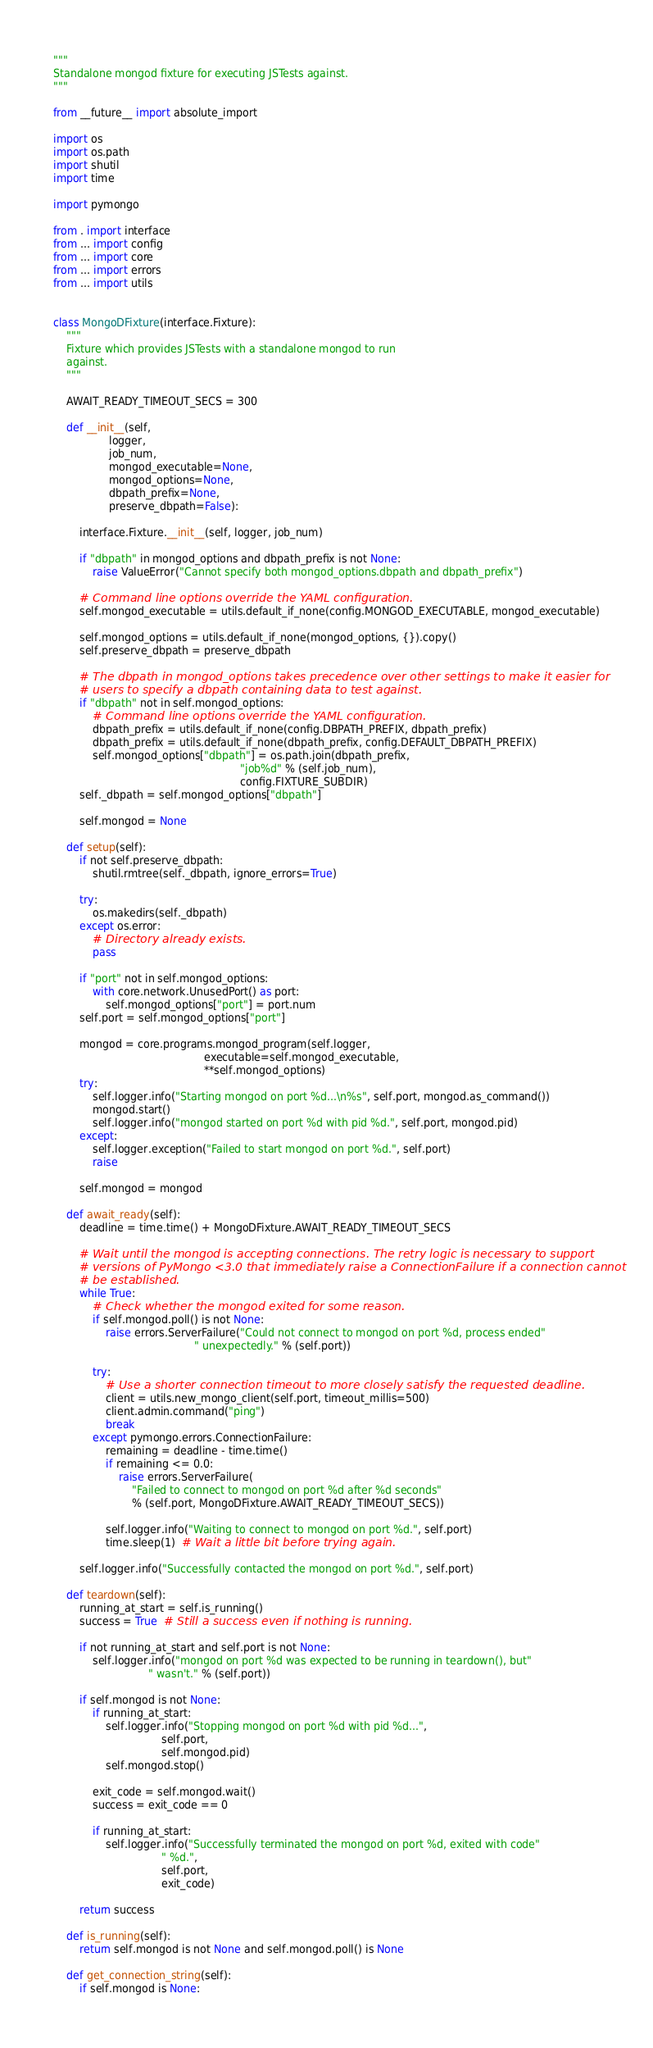<code> <loc_0><loc_0><loc_500><loc_500><_Python_>"""
Standalone mongod fixture for executing JSTests against.
"""

from __future__ import absolute_import

import os
import os.path
import shutil
import time

import pymongo

from . import interface
from ... import config
from ... import core
from ... import errors
from ... import utils


class MongoDFixture(interface.Fixture):
    """
    Fixture which provides JSTests with a standalone mongod to run
    against.
    """

    AWAIT_READY_TIMEOUT_SECS = 300

    def __init__(self,
                 logger,
                 job_num,
                 mongod_executable=None,
                 mongod_options=None,
                 dbpath_prefix=None,
                 preserve_dbpath=False):

        interface.Fixture.__init__(self, logger, job_num)

        if "dbpath" in mongod_options and dbpath_prefix is not None:
            raise ValueError("Cannot specify both mongod_options.dbpath and dbpath_prefix")

        # Command line options override the YAML configuration.
        self.mongod_executable = utils.default_if_none(config.MONGOD_EXECUTABLE, mongod_executable)

        self.mongod_options = utils.default_if_none(mongod_options, {}).copy()
        self.preserve_dbpath = preserve_dbpath

        # The dbpath in mongod_options takes precedence over other settings to make it easier for
        # users to specify a dbpath containing data to test against.
        if "dbpath" not in self.mongod_options:
            # Command line options override the YAML configuration.
            dbpath_prefix = utils.default_if_none(config.DBPATH_PREFIX, dbpath_prefix)
            dbpath_prefix = utils.default_if_none(dbpath_prefix, config.DEFAULT_DBPATH_PREFIX)
            self.mongod_options["dbpath"] = os.path.join(dbpath_prefix,
                                                         "job%d" % (self.job_num),
                                                         config.FIXTURE_SUBDIR)
        self._dbpath = self.mongod_options["dbpath"]

        self.mongod = None

    def setup(self):
        if not self.preserve_dbpath:
            shutil.rmtree(self._dbpath, ignore_errors=True)

        try:
            os.makedirs(self._dbpath)
        except os.error:
            # Directory already exists.
            pass

        if "port" not in self.mongod_options:
            with core.network.UnusedPort() as port:
                self.mongod_options["port"] = port.num
        self.port = self.mongod_options["port"]

        mongod = core.programs.mongod_program(self.logger,
                                              executable=self.mongod_executable,
                                              **self.mongod_options)
        try:
            self.logger.info("Starting mongod on port %d...\n%s", self.port, mongod.as_command())
            mongod.start()
            self.logger.info("mongod started on port %d with pid %d.", self.port, mongod.pid)
        except:
            self.logger.exception("Failed to start mongod on port %d.", self.port)
            raise

        self.mongod = mongod

    def await_ready(self):
        deadline = time.time() + MongoDFixture.AWAIT_READY_TIMEOUT_SECS

        # Wait until the mongod is accepting connections. The retry logic is necessary to support
        # versions of PyMongo <3.0 that immediately raise a ConnectionFailure if a connection cannot
        # be established.
        while True:
            # Check whether the mongod exited for some reason.
            if self.mongod.poll() is not None:
                raise errors.ServerFailure("Could not connect to mongod on port %d, process ended"
                                           " unexpectedly." % (self.port))

            try:
                # Use a shorter connection timeout to more closely satisfy the requested deadline.
                client = utils.new_mongo_client(self.port, timeout_millis=500)
                client.admin.command("ping")
                break
            except pymongo.errors.ConnectionFailure:
                remaining = deadline - time.time()
                if remaining <= 0.0:
                    raise errors.ServerFailure(
                        "Failed to connect to mongod on port %d after %d seconds"
                        % (self.port, MongoDFixture.AWAIT_READY_TIMEOUT_SECS))

                self.logger.info("Waiting to connect to mongod on port %d.", self.port)
                time.sleep(1)  # Wait a little bit before trying again.

        self.logger.info("Successfully contacted the mongod on port %d.", self.port)

    def teardown(self):
        running_at_start = self.is_running()
        success = True  # Still a success even if nothing is running.

        if not running_at_start and self.port is not None:
            self.logger.info("mongod on port %d was expected to be running in teardown(), but"
                             " wasn't." % (self.port))

        if self.mongod is not None:
            if running_at_start:
                self.logger.info("Stopping mongod on port %d with pid %d...",
                                 self.port,
                                 self.mongod.pid)
                self.mongod.stop()

            exit_code = self.mongod.wait()
            success = exit_code == 0

            if running_at_start:
                self.logger.info("Successfully terminated the mongod on port %d, exited with code"
                                 " %d.",
                                 self.port,
                                 exit_code)

        return success

    def is_running(self):
        return self.mongod is not None and self.mongod.poll() is None

    def get_connection_string(self):
        if self.mongod is None:</code> 